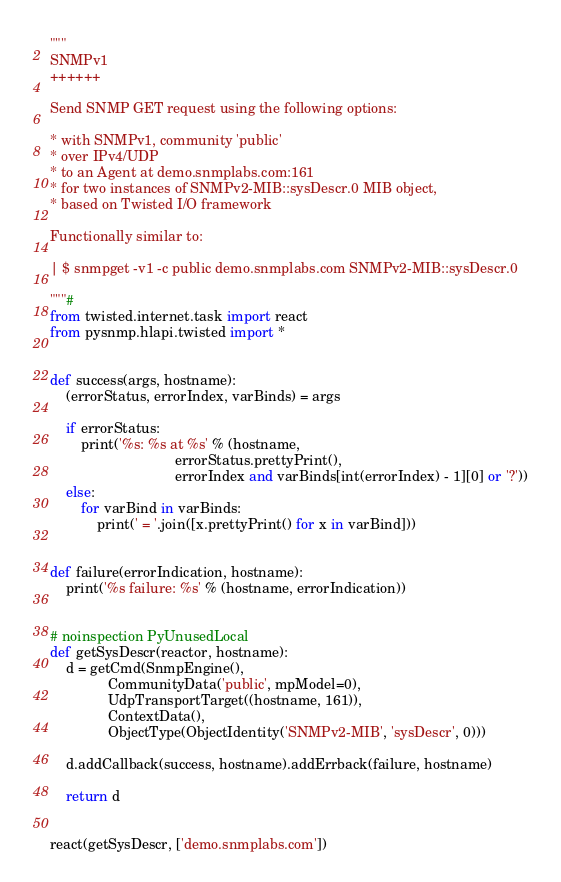<code> <loc_0><loc_0><loc_500><loc_500><_Python_>"""
SNMPv1
++++++

Send SNMP GET request using the following options:

* with SNMPv1, community 'public'
* over IPv4/UDP
* to an Agent at demo.snmplabs.com:161
* for two instances of SNMPv2-MIB::sysDescr.0 MIB object,
* based on Twisted I/O framework

Functionally similar to:

| $ snmpget -v1 -c public demo.snmplabs.com SNMPv2-MIB::sysDescr.0

"""#
from twisted.internet.task import react
from pysnmp.hlapi.twisted import *


def success(args, hostname):
    (errorStatus, errorIndex, varBinds) = args

    if errorStatus:
        print('%s: %s at %s' % (hostname,
                                errorStatus.prettyPrint(),
                                errorIndex and varBinds[int(errorIndex) - 1][0] or '?'))
    else:
        for varBind in varBinds:
            print(' = '.join([x.prettyPrint() for x in varBind]))


def failure(errorIndication, hostname):
    print('%s failure: %s' % (hostname, errorIndication))


# noinspection PyUnusedLocal
def getSysDescr(reactor, hostname):
    d = getCmd(SnmpEngine(),
               CommunityData('public', mpModel=0),
               UdpTransportTarget((hostname, 161)),
               ContextData(),
               ObjectType(ObjectIdentity('SNMPv2-MIB', 'sysDescr', 0)))

    d.addCallback(success, hostname).addErrback(failure, hostname)

    return d


react(getSysDescr, ['demo.snmplabs.com'])
</code> 